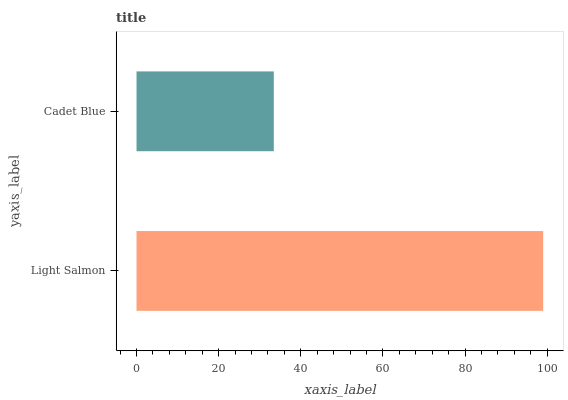Is Cadet Blue the minimum?
Answer yes or no. Yes. Is Light Salmon the maximum?
Answer yes or no. Yes. Is Cadet Blue the maximum?
Answer yes or no. No. Is Light Salmon greater than Cadet Blue?
Answer yes or no. Yes. Is Cadet Blue less than Light Salmon?
Answer yes or no. Yes. Is Cadet Blue greater than Light Salmon?
Answer yes or no. No. Is Light Salmon less than Cadet Blue?
Answer yes or no. No. Is Light Salmon the high median?
Answer yes or no. Yes. Is Cadet Blue the low median?
Answer yes or no. Yes. Is Cadet Blue the high median?
Answer yes or no. No. Is Light Salmon the low median?
Answer yes or no. No. 